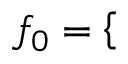Convert formula to latex. <formula><loc_0><loc_0><loc_500><loc_500>{ { f } _ { 0 } } = \left \{ \begin{array} { r l } \end{array}</formula> 